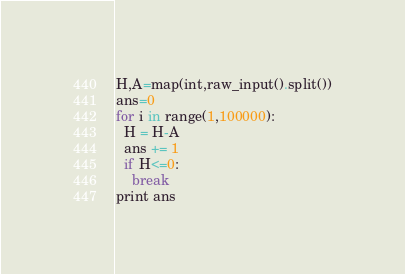Convert code to text. <code><loc_0><loc_0><loc_500><loc_500><_Python_>H,A=map(int,raw_input().split())
ans=0
for i in range(1,100000):
  H = H-A
  ans += 1
  if H<=0:
    break
print ans</code> 